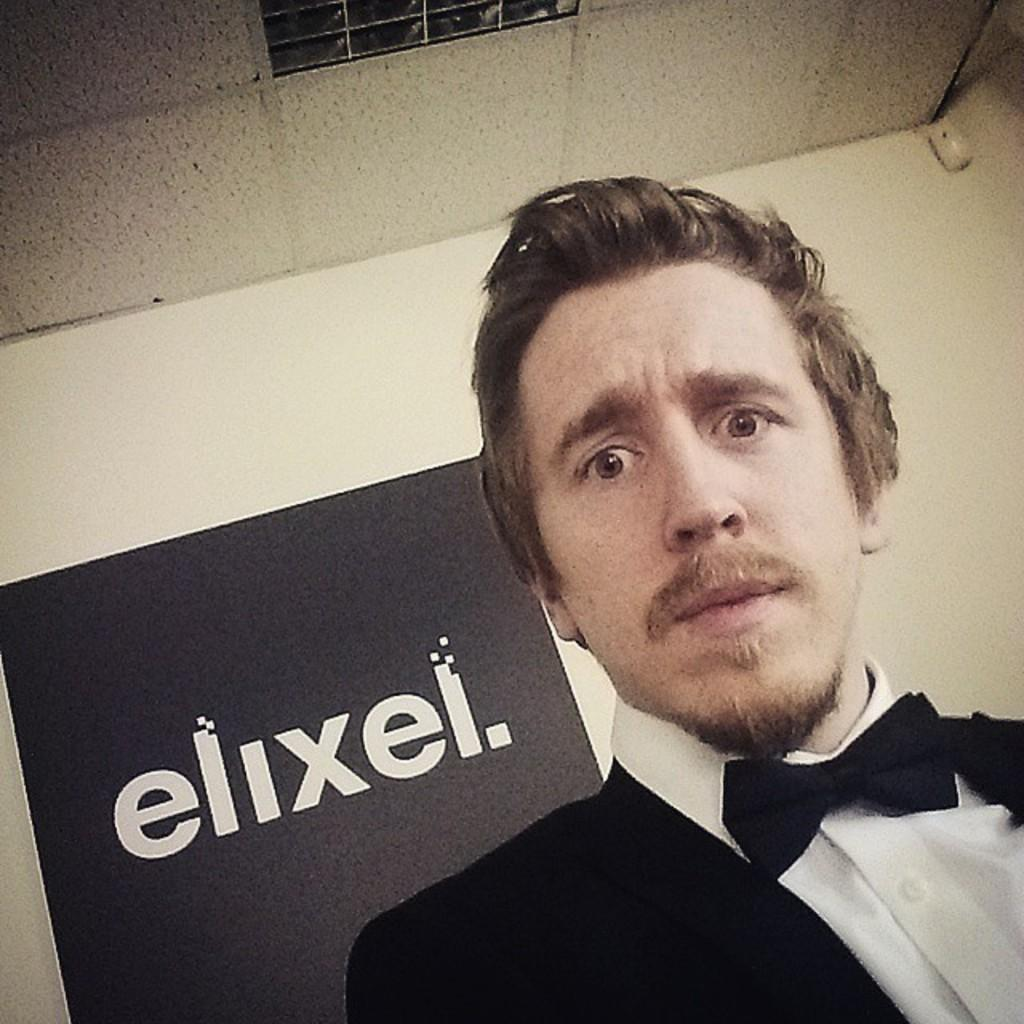Who is present in the image? There is a man in the image. What can be seen in the background of the image? There is a banner, a wall, and a roof in the background of the image. What type of tent can be seen on the ground in the image? There is no tent present in the image; it features a man and background elements such as a banner, wall, and roof. 